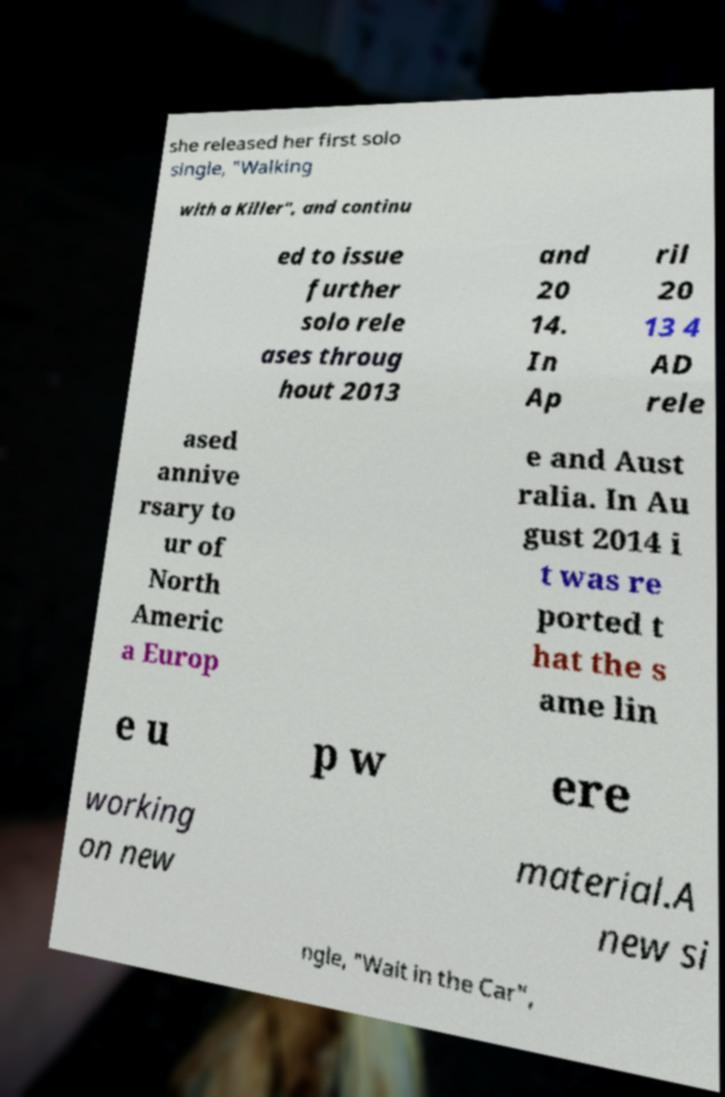Please read and relay the text visible in this image. What does it say? she released her first solo single, "Walking with a Killer", and continu ed to issue further solo rele ases throug hout 2013 and 20 14. In Ap ril 20 13 4 AD rele ased annive rsary to ur of North Americ a Europ e and Aust ralia. In Au gust 2014 i t was re ported t hat the s ame lin e u p w ere working on new material.A new si ngle, "Wait in the Car", 